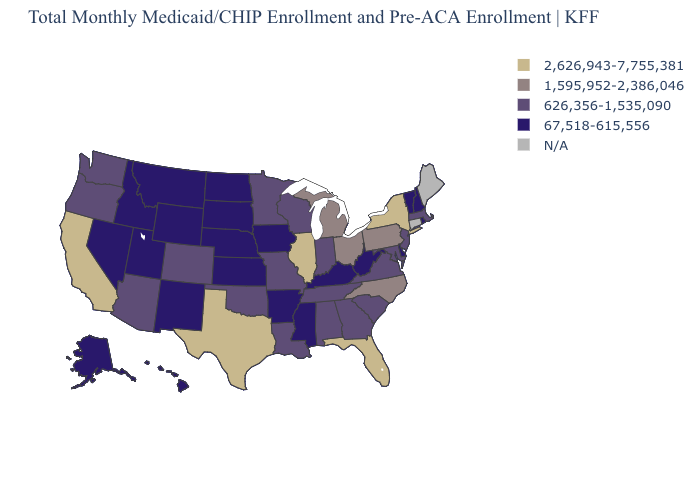Name the states that have a value in the range 1,595,952-2,386,046?
Answer briefly. Michigan, North Carolina, Ohio, Pennsylvania. What is the value of Kentucky?
Concise answer only. 67,518-615,556. What is the value of Minnesota?
Short answer required. 626,356-1,535,090. Name the states that have a value in the range 626,356-1,535,090?
Concise answer only. Alabama, Arizona, Colorado, Georgia, Indiana, Louisiana, Maryland, Massachusetts, Minnesota, Missouri, New Jersey, Oklahoma, Oregon, South Carolina, Tennessee, Virginia, Washington, Wisconsin. Among the states that border Texas , does Oklahoma have the highest value?
Keep it brief. Yes. Among the states that border Connecticut , which have the lowest value?
Give a very brief answer. Rhode Island. Among the states that border Minnesota , which have the lowest value?
Concise answer only. Iowa, North Dakota, South Dakota. Which states have the highest value in the USA?
Keep it brief. California, Florida, Illinois, New York, Texas. What is the value of Virginia?
Concise answer only. 626,356-1,535,090. What is the lowest value in the South?
Short answer required. 67,518-615,556. What is the value of Rhode Island?
Quick response, please. 67,518-615,556. What is the highest value in states that border Utah?
Keep it brief. 626,356-1,535,090. Name the states that have a value in the range 2,626,943-7,755,381?
Answer briefly. California, Florida, Illinois, New York, Texas. Does California have the highest value in the West?
Answer briefly. Yes. Does the first symbol in the legend represent the smallest category?
Give a very brief answer. No. 